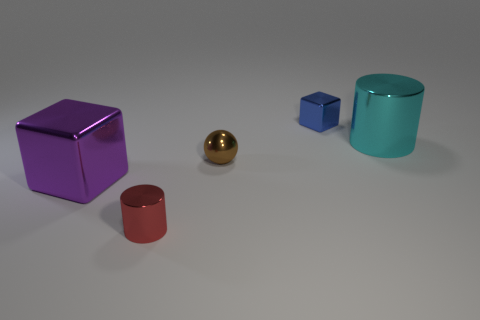Do the small red object and the small brown metallic thing that is left of the big metal cylinder have the same shape?
Provide a short and direct response. No. How many things are both left of the tiny blue metal cube and behind the small sphere?
Make the answer very short. 0. What material is the tiny thing that is the same shape as the big purple thing?
Provide a short and direct response. Metal. There is a metallic cube to the right of the cylinder that is left of the small cube; what is its size?
Provide a succinct answer. Small. Are there any small blue cubes?
Offer a very short reply. Yes. The object that is right of the ball and to the left of the cyan metal object is made of what material?
Your response must be concise. Metal. Are there more cyan metal objects to the left of the tiny metal cylinder than blocks right of the small metallic block?
Provide a succinct answer. No. Are there any yellow rubber cylinders that have the same size as the brown shiny object?
Keep it short and to the point. No. What size is the metal cube that is to the right of the large thing that is left of the small object behind the big shiny cylinder?
Provide a short and direct response. Small. The tiny metallic cylinder is what color?
Your response must be concise. Red. 